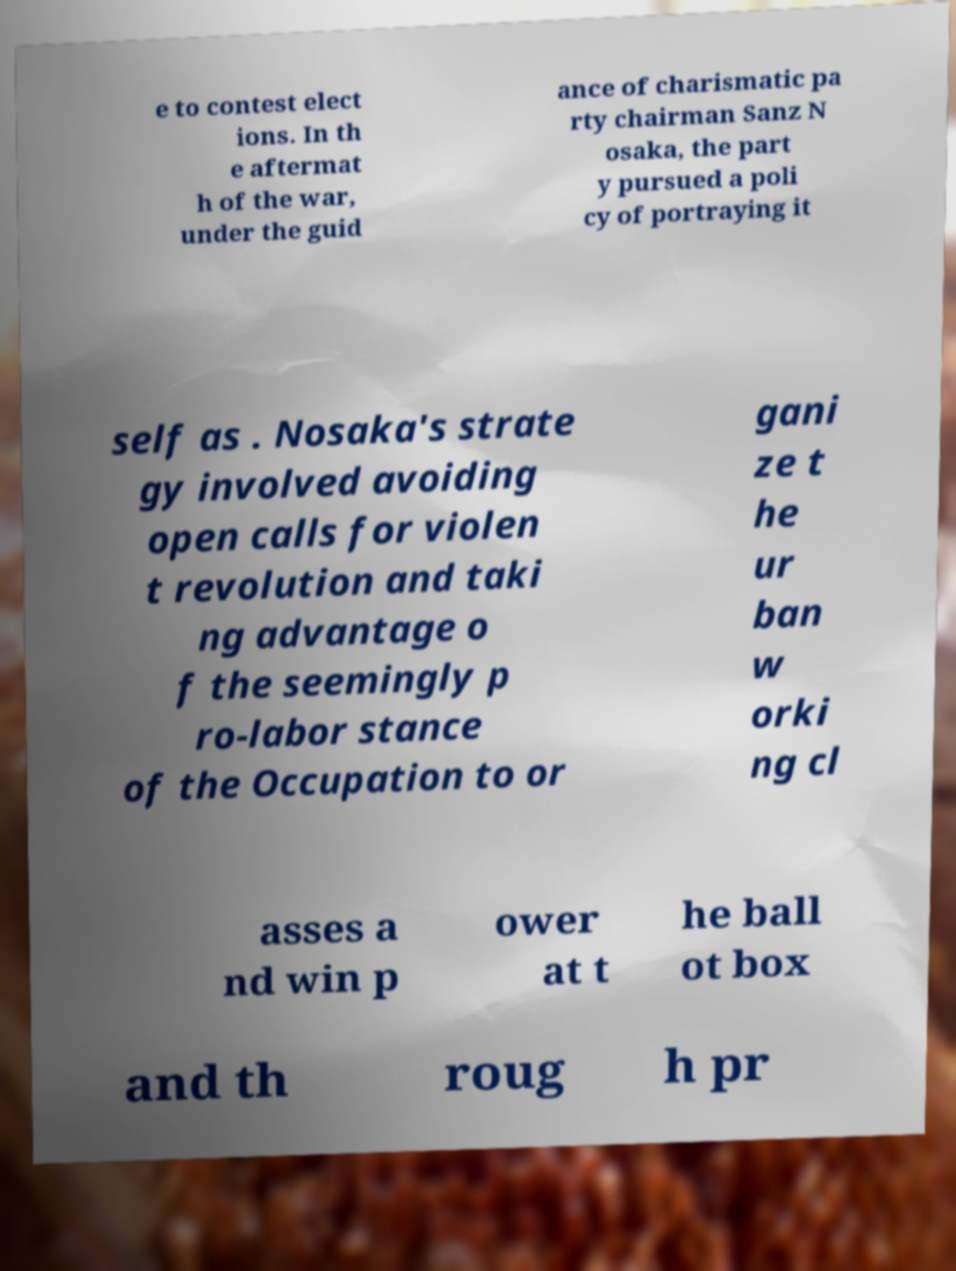What messages or text are displayed in this image? I need them in a readable, typed format. e to contest elect ions. In th e aftermat h of the war, under the guid ance of charismatic pa rty chairman Sanz N osaka, the part y pursued a poli cy of portraying it self as . Nosaka's strate gy involved avoiding open calls for violen t revolution and taki ng advantage o f the seemingly p ro-labor stance of the Occupation to or gani ze t he ur ban w orki ng cl asses a nd win p ower at t he ball ot box and th roug h pr 